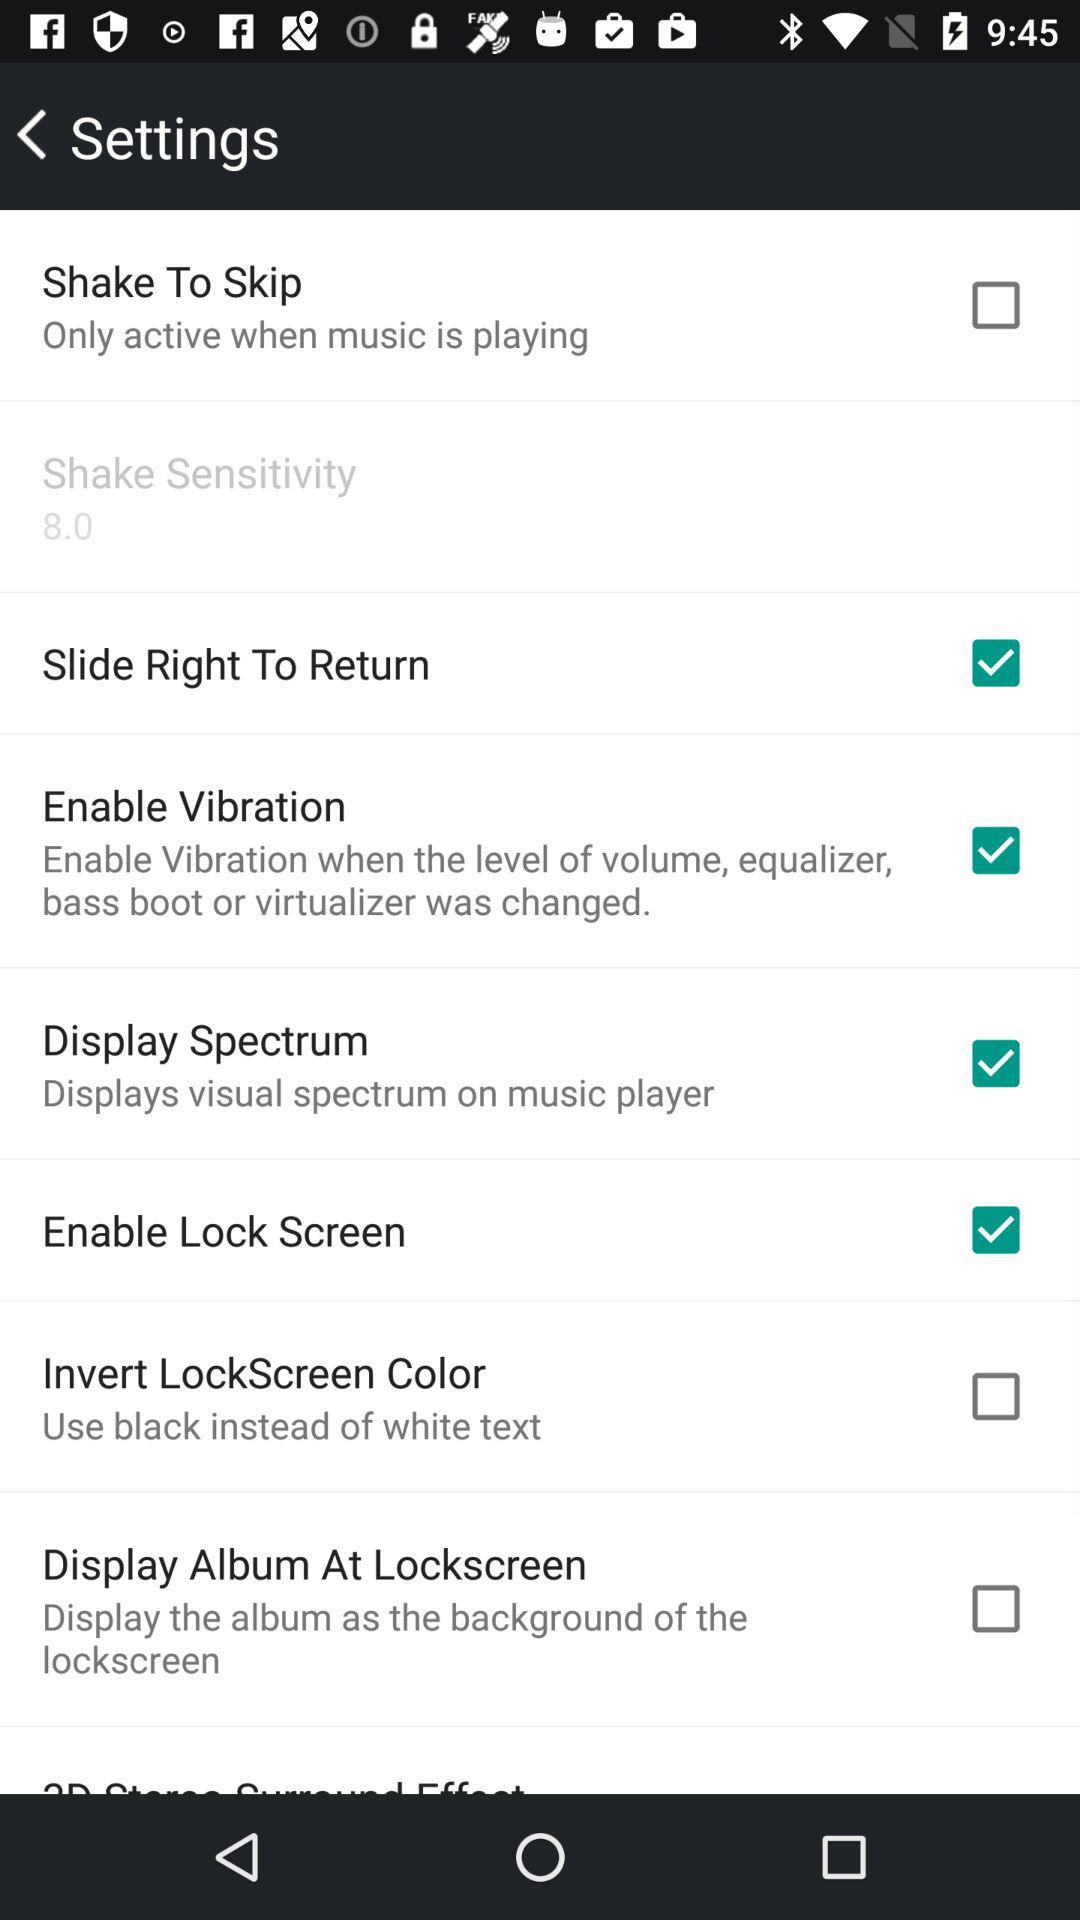What options are checked? The checked options are "Slide Right To Return", "Enable Vibration", "Display Spectrum" and "Enable Lock Screen". 